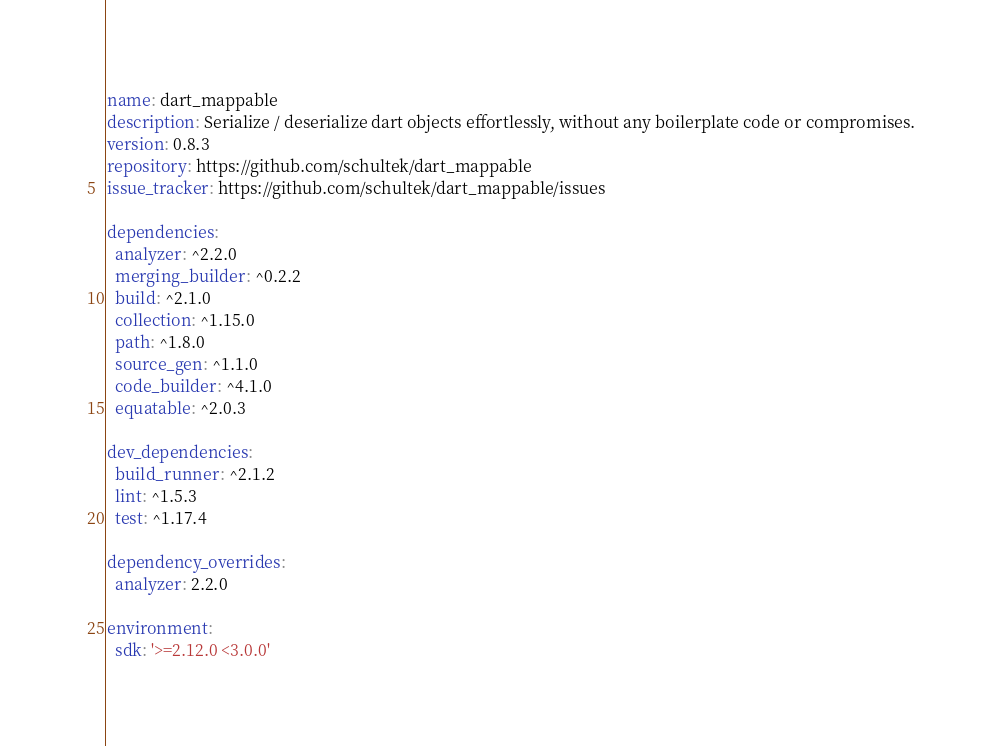<code> <loc_0><loc_0><loc_500><loc_500><_YAML_>name: dart_mappable
description: Serialize / deserialize dart objects effortlessly, without any boilerplate code or compromises.
version: 0.8.3
repository: https://github.com/schultek/dart_mappable
issue_tracker: https://github.com/schultek/dart_mappable/issues

dependencies:
  analyzer: ^2.2.0
  merging_builder: ^0.2.2
  build: ^2.1.0
  collection: ^1.15.0
  path: ^1.8.0
  source_gen: ^1.1.0
  code_builder: ^4.1.0
  equatable: ^2.0.3

dev_dependencies:
  build_runner: ^2.1.2
  lint: ^1.5.3
  test: ^1.17.4

dependency_overrides:
  analyzer: 2.2.0

environment:
  sdk: '>=2.12.0 <3.0.0'
</code> 